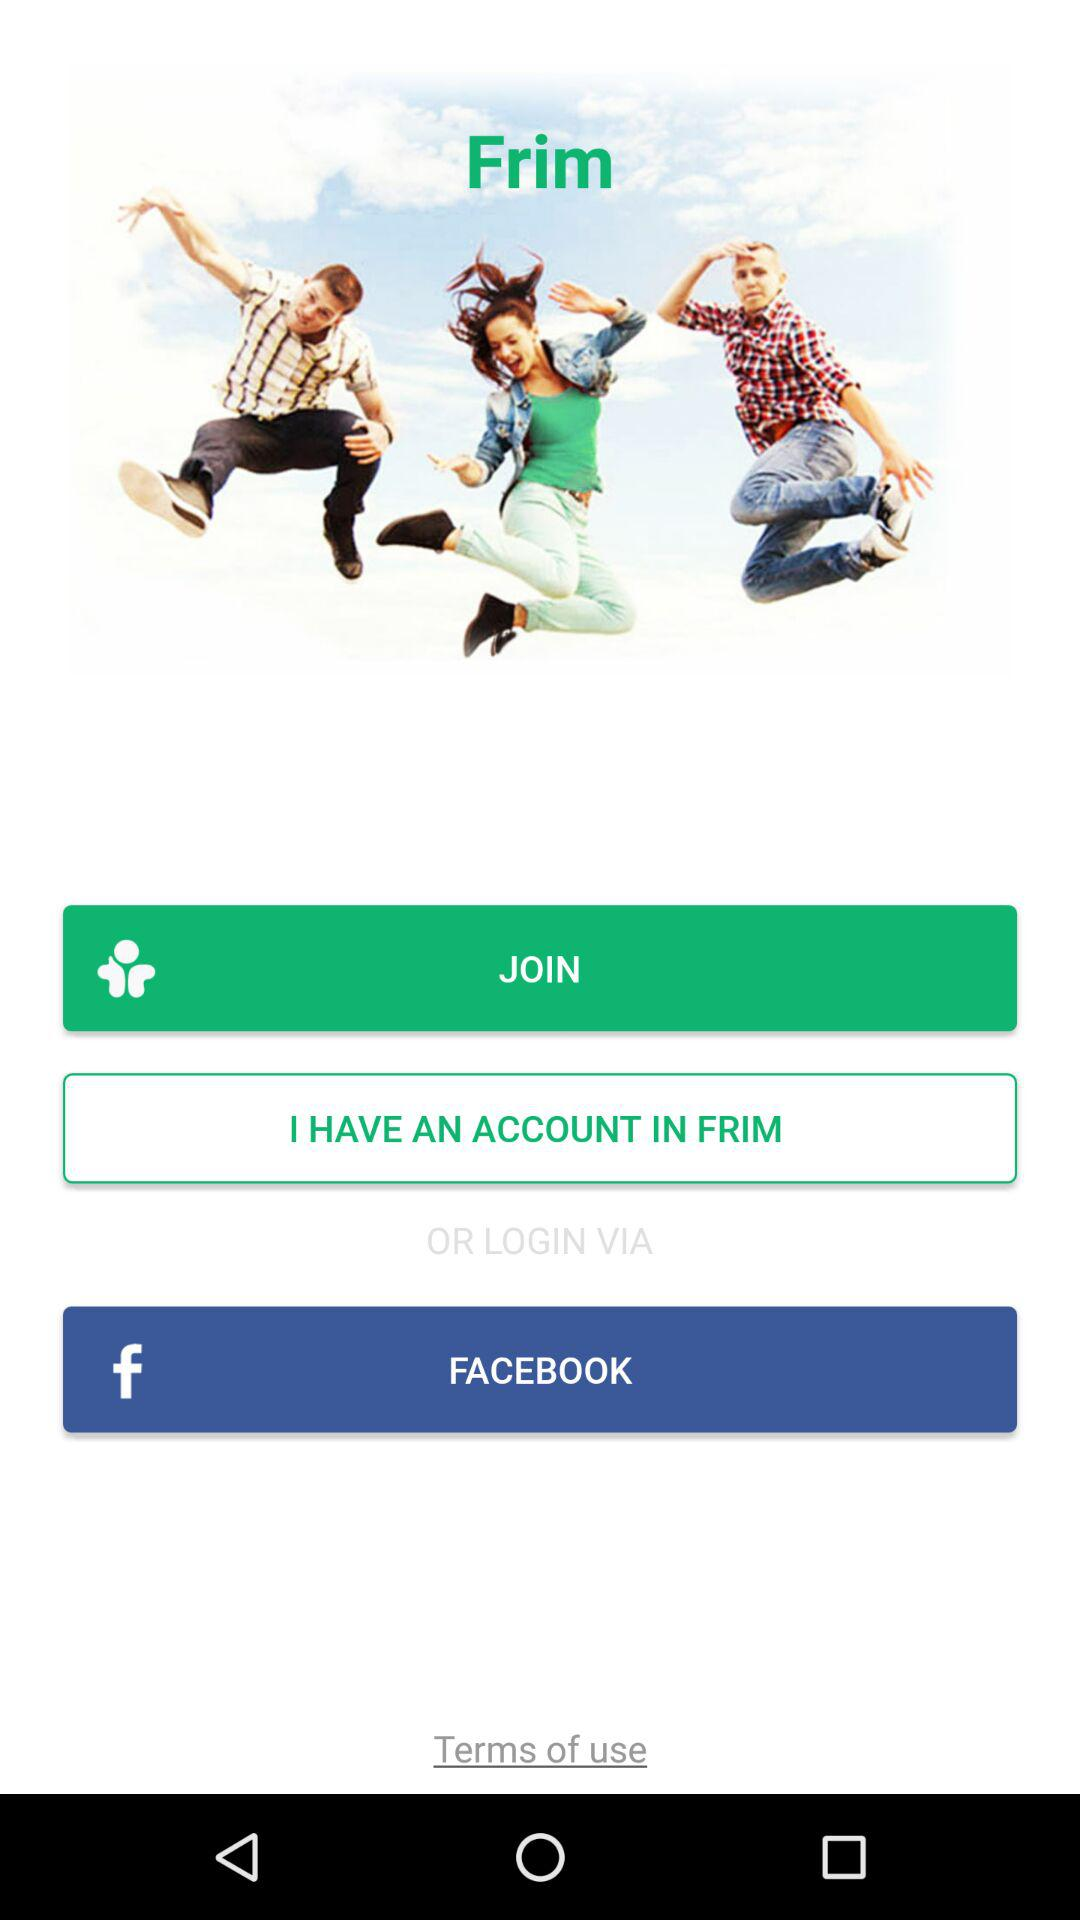What is the other application through which we can log in? The other application through which you can log in is "FACEBOOK". 